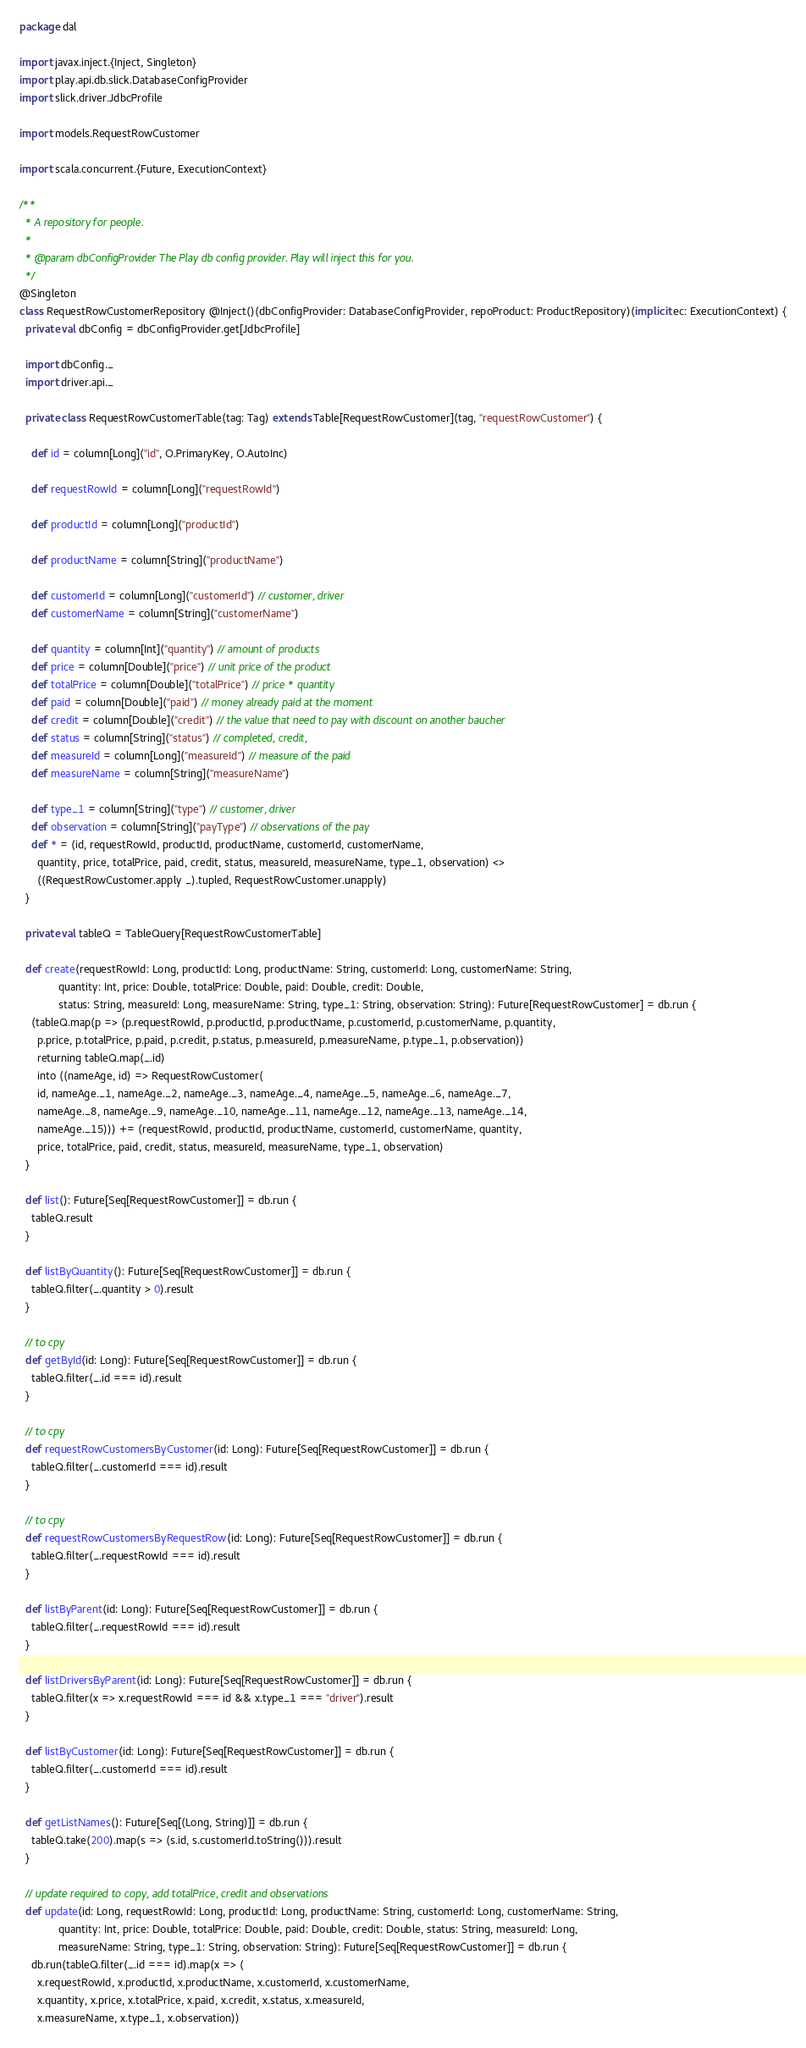<code> <loc_0><loc_0><loc_500><loc_500><_Scala_>package dal

import javax.inject.{Inject, Singleton}
import play.api.db.slick.DatabaseConfigProvider
import slick.driver.JdbcProfile

import models.RequestRowCustomer

import scala.concurrent.{Future, ExecutionContext}

/**
  * A repository for people.
  *
  * @param dbConfigProvider The Play db config provider. Play will inject this for you.
  */
@Singleton
class RequestRowCustomerRepository @Inject()(dbConfigProvider: DatabaseConfigProvider, repoProduct: ProductRepository)(implicit ec: ExecutionContext) {
  private val dbConfig = dbConfigProvider.get[JdbcProfile]

  import dbConfig._
  import driver.api._

  private class RequestRowCustomerTable(tag: Tag) extends Table[RequestRowCustomer](tag, "requestRowCustomer") {

    def id = column[Long]("id", O.PrimaryKey, O.AutoInc)

    def requestRowId = column[Long]("requestRowId")

    def productId = column[Long]("productId")

    def productName = column[String]("productName")

    def customerId = column[Long]("customerId") // customer, driver
    def customerName = column[String]("customerName")

    def quantity = column[Int]("quantity") // amount of products
    def price = column[Double]("price") // unit price of the product
    def totalPrice = column[Double]("totalPrice") // price * quantity
    def paid = column[Double]("paid") // money already paid at the moment
    def credit = column[Double]("credit") // the value that need to pay with discount on another baucher
    def status = column[String]("status") // completed, credit, 
    def measureId = column[Long]("measureId") // measure of the paid
    def measureName = column[String]("measureName")

    def type_1 = column[String]("type") // customer, driver
    def observation = column[String]("payType") // observations of the pay
    def * = (id, requestRowId, productId, productName, customerId, customerName,
      quantity, price, totalPrice, paid, credit, status, measureId, measureName, type_1, observation) <>
      ((RequestRowCustomer.apply _).tupled, RequestRowCustomer.unapply)
  }

  private val tableQ = TableQuery[RequestRowCustomerTable]

  def create(requestRowId: Long, productId: Long, productName: String, customerId: Long, customerName: String,
             quantity: Int, price: Double, totalPrice: Double, paid: Double, credit: Double,
             status: String, measureId: Long, measureName: String, type_1: String, observation: String): Future[RequestRowCustomer] = db.run {
    (tableQ.map(p => (p.requestRowId, p.productId, p.productName, p.customerId, p.customerName, p.quantity,
      p.price, p.totalPrice, p.paid, p.credit, p.status, p.measureId, p.measureName, p.type_1, p.observation))
      returning tableQ.map(_.id)
      into ((nameAge, id) => RequestRowCustomer(
      id, nameAge._1, nameAge._2, nameAge._3, nameAge._4, nameAge._5, nameAge._6, nameAge._7,
      nameAge._8, nameAge._9, nameAge._10, nameAge._11, nameAge._12, nameAge._13, nameAge._14,
      nameAge._15))) += (requestRowId, productId, productName, customerId, customerName, quantity,
      price, totalPrice, paid, credit, status, measureId, measureName, type_1, observation)
  }

  def list(): Future[Seq[RequestRowCustomer]] = db.run {
    tableQ.result
  }

  def listByQuantity(): Future[Seq[RequestRowCustomer]] = db.run {
    tableQ.filter(_.quantity > 0).result
  }

  // to cpy
  def getById(id: Long): Future[Seq[RequestRowCustomer]] = db.run {
    tableQ.filter(_.id === id).result
  }

  // to cpy
  def requestRowCustomersByCustomer(id: Long): Future[Seq[RequestRowCustomer]] = db.run {
    tableQ.filter(_.customerId === id).result
  }

  // to cpy
  def requestRowCustomersByRequestRow(id: Long): Future[Seq[RequestRowCustomer]] = db.run {
    tableQ.filter(_.requestRowId === id).result
  }

  def listByParent(id: Long): Future[Seq[RequestRowCustomer]] = db.run {
    tableQ.filter(_.requestRowId === id).result
  }

  def listDriversByParent(id: Long): Future[Seq[RequestRowCustomer]] = db.run {
    tableQ.filter(x => x.requestRowId === id && x.type_1 === "driver").result
  }

  def listByCustomer(id: Long): Future[Seq[RequestRowCustomer]] = db.run {
    tableQ.filter(_.customerId === id).result
  }

  def getListNames(): Future[Seq[(Long, String)]] = db.run {
    tableQ.take(200).map(s => (s.id, s.customerId.toString())).result
  }

  // update required to copy, add totalPrice, credit and observations
  def update(id: Long, requestRowId: Long, productId: Long, productName: String, customerId: Long, customerName: String,
             quantity: Int, price: Double, totalPrice: Double, paid: Double, credit: Double, status: String, measureId: Long,
             measureName: String, type_1: String, observation: String): Future[Seq[RequestRowCustomer]] = db.run {
    db.run(tableQ.filter(_.id === id).map(x => (
      x.requestRowId, x.productId, x.productName, x.customerId, x.customerName,
      x.quantity, x.price, x.totalPrice, x.paid, x.credit, x.status, x.measureId,
      x.measureName, x.type_1, x.observation))</code> 